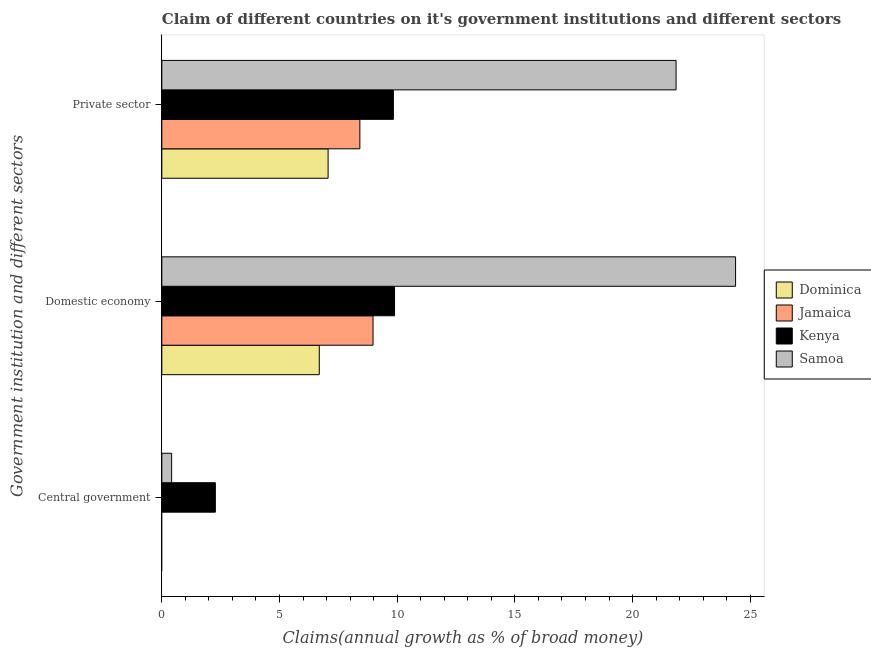How many groups of bars are there?
Provide a short and direct response. 3. Are the number of bars per tick equal to the number of legend labels?
Make the answer very short. No. Are the number of bars on each tick of the Y-axis equal?
Provide a succinct answer. No. What is the label of the 1st group of bars from the top?
Provide a succinct answer. Private sector. What is the percentage of claim on the domestic economy in Kenya?
Keep it short and to the point. 9.89. Across all countries, what is the maximum percentage of claim on the domestic economy?
Ensure brevity in your answer.  24.37. Across all countries, what is the minimum percentage of claim on the private sector?
Give a very brief answer. 7.06. In which country was the percentage of claim on the domestic economy maximum?
Your response must be concise. Samoa. What is the total percentage of claim on the central government in the graph?
Make the answer very short. 2.69. What is the difference between the percentage of claim on the private sector in Dominica and that in Samoa?
Offer a very short reply. -14.78. What is the difference between the percentage of claim on the central government in Kenya and the percentage of claim on the private sector in Samoa?
Your response must be concise. -19.57. What is the average percentage of claim on the private sector per country?
Your response must be concise. 11.79. What is the difference between the percentage of claim on the domestic economy and percentage of claim on the central government in Samoa?
Provide a short and direct response. 23.96. What is the ratio of the percentage of claim on the domestic economy in Samoa to that in Kenya?
Provide a short and direct response. 2.47. Is the percentage of claim on the private sector in Samoa less than that in Dominica?
Your answer should be compact. No. Is the difference between the percentage of claim on the private sector in Dominica and Samoa greater than the difference between the percentage of claim on the domestic economy in Dominica and Samoa?
Make the answer very short. Yes. What is the difference between the highest and the second highest percentage of claim on the domestic economy?
Your answer should be very brief. 14.49. What is the difference between the highest and the lowest percentage of claim on the private sector?
Provide a short and direct response. 14.78. In how many countries, is the percentage of claim on the domestic economy greater than the average percentage of claim on the domestic economy taken over all countries?
Your answer should be very brief. 1. How many countries are there in the graph?
Make the answer very short. 4. Does the graph contain any zero values?
Give a very brief answer. Yes. Does the graph contain grids?
Keep it short and to the point. No. Where does the legend appear in the graph?
Your answer should be very brief. Center right. What is the title of the graph?
Make the answer very short. Claim of different countries on it's government institutions and different sectors. What is the label or title of the X-axis?
Your response must be concise. Claims(annual growth as % of broad money). What is the label or title of the Y-axis?
Provide a short and direct response. Government institution and different sectors. What is the Claims(annual growth as % of broad money) in Dominica in Central government?
Ensure brevity in your answer.  0. What is the Claims(annual growth as % of broad money) of Jamaica in Central government?
Offer a very short reply. 0. What is the Claims(annual growth as % of broad money) of Kenya in Central government?
Offer a terse response. 2.27. What is the Claims(annual growth as % of broad money) of Samoa in Central government?
Offer a terse response. 0.42. What is the Claims(annual growth as % of broad money) of Dominica in Domestic economy?
Your answer should be compact. 6.69. What is the Claims(annual growth as % of broad money) in Jamaica in Domestic economy?
Offer a very short reply. 8.97. What is the Claims(annual growth as % of broad money) of Kenya in Domestic economy?
Keep it short and to the point. 9.89. What is the Claims(annual growth as % of broad money) of Samoa in Domestic economy?
Your answer should be compact. 24.37. What is the Claims(annual growth as % of broad money) in Dominica in Private sector?
Your answer should be very brief. 7.06. What is the Claims(annual growth as % of broad money) in Jamaica in Private sector?
Your response must be concise. 8.41. What is the Claims(annual growth as % of broad money) of Kenya in Private sector?
Offer a terse response. 9.84. What is the Claims(annual growth as % of broad money) of Samoa in Private sector?
Provide a short and direct response. 21.85. Across all Government institution and different sectors, what is the maximum Claims(annual growth as % of broad money) of Dominica?
Provide a short and direct response. 7.06. Across all Government institution and different sectors, what is the maximum Claims(annual growth as % of broad money) of Jamaica?
Your answer should be very brief. 8.97. Across all Government institution and different sectors, what is the maximum Claims(annual growth as % of broad money) of Kenya?
Offer a terse response. 9.89. Across all Government institution and different sectors, what is the maximum Claims(annual growth as % of broad money) in Samoa?
Provide a short and direct response. 24.37. Across all Government institution and different sectors, what is the minimum Claims(annual growth as % of broad money) of Kenya?
Offer a very short reply. 2.27. Across all Government institution and different sectors, what is the minimum Claims(annual growth as % of broad money) of Samoa?
Offer a terse response. 0.42. What is the total Claims(annual growth as % of broad money) in Dominica in the graph?
Provide a short and direct response. 13.75. What is the total Claims(annual growth as % of broad money) of Jamaica in the graph?
Provide a succinct answer. 17.39. What is the total Claims(annual growth as % of broad money) in Kenya in the graph?
Provide a short and direct response. 22. What is the total Claims(annual growth as % of broad money) in Samoa in the graph?
Your answer should be compact. 46.64. What is the difference between the Claims(annual growth as % of broad money) of Kenya in Central government and that in Domestic economy?
Your answer should be compact. -7.61. What is the difference between the Claims(annual growth as % of broad money) of Samoa in Central government and that in Domestic economy?
Offer a terse response. -23.96. What is the difference between the Claims(annual growth as % of broad money) of Kenya in Central government and that in Private sector?
Offer a terse response. -7.56. What is the difference between the Claims(annual growth as % of broad money) of Samoa in Central government and that in Private sector?
Ensure brevity in your answer.  -21.43. What is the difference between the Claims(annual growth as % of broad money) in Dominica in Domestic economy and that in Private sector?
Give a very brief answer. -0.37. What is the difference between the Claims(annual growth as % of broad money) of Jamaica in Domestic economy and that in Private sector?
Your response must be concise. 0.56. What is the difference between the Claims(annual growth as % of broad money) in Kenya in Domestic economy and that in Private sector?
Provide a succinct answer. 0.05. What is the difference between the Claims(annual growth as % of broad money) of Samoa in Domestic economy and that in Private sector?
Provide a short and direct response. 2.53. What is the difference between the Claims(annual growth as % of broad money) of Kenya in Central government and the Claims(annual growth as % of broad money) of Samoa in Domestic economy?
Offer a very short reply. -22.1. What is the difference between the Claims(annual growth as % of broad money) of Kenya in Central government and the Claims(annual growth as % of broad money) of Samoa in Private sector?
Your answer should be compact. -19.57. What is the difference between the Claims(annual growth as % of broad money) in Dominica in Domestic economy and the Claims(annual growth as % of broad money) in Jamaica in Private sector?
Provide a short and direct response. -1.72. What is the difference between the Claims(annual growth as % of broad money) of Dominica in Domestic economy and the Claims(annual growth as % of broad money) of Kenya in Private sector?
Provide a short and direct response. -3.15. What is the difference between the Claims(annual growth as % of broad money) in Dominica in Domestic economy and the Claims(annual growth as % of broad money) in Samoa in Private sector?
Give a very brief answer. -15.16. What is the difference between the Claims(annual growth as % of broad money) in Jamaica in Domestic economy and the Claims(annual growth as % of broad money) in Kenya in Private sector?
Offer a very short reply. -0.86. What is the difference between the Claims(annual growth as % of broad money) in Jamaica in Domestic economy and the Claims(annual growth as % of broad money) in Samoa in Private sector?
Keep it short and to the point. -12.88. What is the difference between the Claims(annual growth as % of broad money) of Kenya in Domestic economy and the Claims(annual growth as % of broad money) of Samoa in Private sector?
Make the answer very short. -11.96. What is the average Claims(annual growth as % of broad money) in Dominica per Government institution and different sectors?
Provide a succinct answer. 4.58. What is the average Claims(annual growth as % of broad money) of Jamaica per Government institution and different sectors?
Ensure brevity in your answer.  5.8. What is the average Claims(annual growth as % of broad money) of Kenya per Government institution and different sectors?
Your response must be concise. 7.33. What is the average Claims(annual growth as % of broad money) in Samoa per Government institution and different sectors?
Make the answer very short. 15.55. What is the difference between the Claims(annual growth as % of broad money) of Kenya and Claims(annual growth as % of broad money) of Samoa in Central government?
Offer a very short reply. 1.86. What is the difference between the Claims(annual growth as % of broad money) of Dominica and Claims(annual growth as % of broad money) of Jamaica in Domestic economy?
Offer a very short reply. -2.28. What is the difference between the Claims(annual growth as % of broad money) in Dominica and Claims(annual growth as % of broad money) in Kenya in Domestic economy?
Your answer should be compact. -3.2. What is the difference between the Claims(annual growth as % of broad money) in Dominica and Claims(annual growth as % of broad money) in Samoa in Domestic economy?
Provide a short and direct response. -17.69. What is the difference between the Claims(annual growth as % of broad money) of Jamaica and Claims(annual growth as % of broad money) of Kenya in Domestic economy?
Ensure brevity in your answer.  -0.91. What is the difference between the Claims(annual growth as % of broad money) of Jamaica and Claims(annual growth as % of broad money) of Samoa in Domestic economy?
Your answer should be very brief. -15.4. What is the difference between the Claims(annual growth as % of broad money) in Kenya and Claims(annual growth as % of broad money) in Samoa in Domestic economy?
Provide a short and direct response. -14.49. What is the difference between the Claims(annual growth as % of broad money) in Dominica and Claims(annual growth as % of broad money) in Jamaica in Private sector?
Ensure brevity in your answer.  -1.35. What is the difference between the Claims(annual growth as % of broad money) of Dominica and Claims(annual growth as % of broad money) of Kenya in Private sector?
Keep it short and to the point. -2.77. What is the difference between the Claims(annual growth as % of broad money) of Dominica and Claims(annual growth as % of broad money) of Samoa in Private sector?
Your answer should be very brief. -14.78. What is the difference between the Claims(annual growth as % of broad money) of Jamaica and Claims(annual growth as % of broad money) of Kenya in Private sector?
Make the answer very short. -1.42. What is the difference between the Claims(annual growth as % of broad money) in Jamaica and Claims(annual growth as % of broad money) in Samoa in Private sector?
Your answer should be very brief. -13.43. What is the difference between the Claims(annual growth as % of broad money) of Kenya and Claims(annual growth as % of broad money) of Samoa in Private sector?
Your response must be concise. -12.01. What is the ratio of the Claims(annual growth as % of broad money) in Kenya in Central government to that in Domestic economy?
Your response must be concise. 0.23. What is the ratio of the Claims(annual growth as % of broad money) in Samoa in Central government to that in Domestic economy?
Ensure brevity in your answer.  0.02. What is the ratio of the Claims(annual growth as % of broad money) in Kenya in Central government to that in Private sector?
Offer a very short reply. 0.23. What is the ratio of the Claims(annual growth as % of broad money) in Samoa in Central government to that in Private sector?
Provide a succinct answer. 0.02. What is the ratio of the Claims(annual growth as % of broad money) in Dominica in Domestic economy to that in Private sector?
Offer a terse response. 0.95. What is the ratio of the Claims(annual growth as % of broad money) of Jamaica in Domestic economy to that in Private sector?
Your response must be concise. 1.07. What is the ratio of the Claims(annual growth as % of broad money) of Kenya in Domestic economy to that in Private sector?
Provide a short and direct response. 1.01. What is the ratio of the Claims(annual growth as % of broad money) of Samoa in Domestic economy to that in Private sector?
Make the answer very short. 1.12. What is the difference between the highest and the second highest Claims(annual growth as % of broad money) in Kenya?
Your answer should be very brief. 0.05. What is the difference between the highest and the second highest Claims(annual growth as % of broad money) in Samoa?
Your response must be concise. 2.53. What is the difference between the highest and the lowest Claims(annual growth as % of broad money) of Dominica?
Provide a short and direct response. 7.06. What is the difference between the highest and the lowest Claims(annual growth as % of broad money) of Jamaica?
Offer a terse response. 8.97. What is the difference between the highest and the lowest Claims(annual growth as % of broad money) in Kenya?
Offer a terse response. 7.61. What is the difference between the highest and the lowest Claims(annual growth as % of broad money) of Samoa?
Your response must be concise. 23.96. 